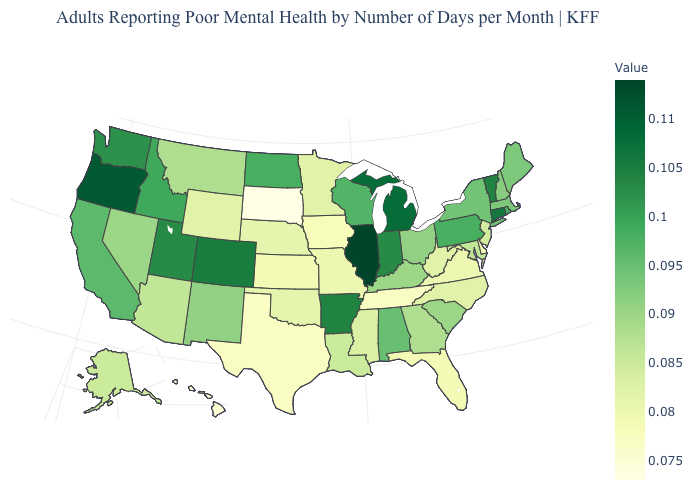Does Arkansas have the highest value in the South?
Give a very brief answer. Yes. Among the states that border Montana , does Idaho have the highest value?
Answer briefly. Yes. Which states have the lowest value in the USA?
Give a very brief answer. South Dakota. Is the legend a continuous bar?
Short answer required. Yes. Among the states that border Idaho , which have the highest value?
Be succinct. Oregon. Does New York have the highest value in the USA?
Keep it brief. No. 